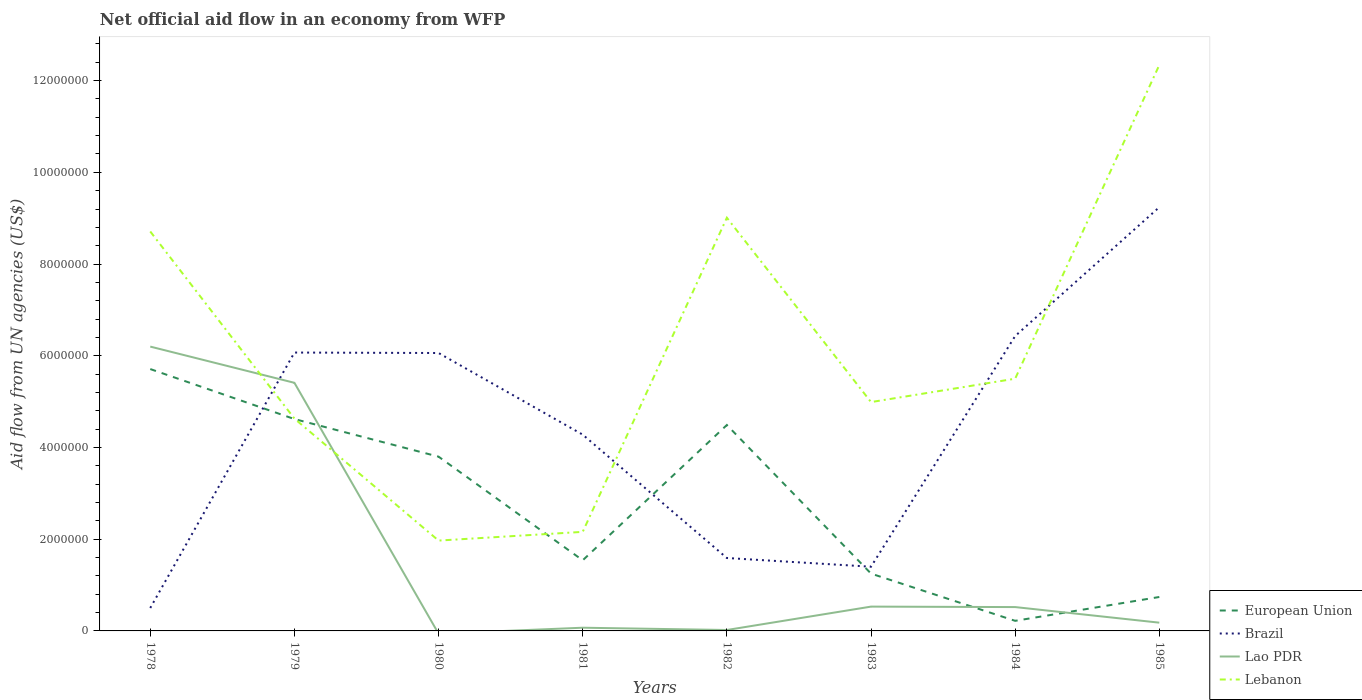How many different coloured lines are there?
Give a very brief answer. 4. Does the line corresponding to European Union intersect with the line corresponding to Lao PDR?
Offer a terse response. Yes. Across all years, what is the maximum net official aid flow in Brazil?
Provide a short and direct response. 5.00e+05. What is the total net official aid flow in European Union in the graph?
Give a very brief answer. 3.08e+06. What is the difference between the highest and the second highest net official aid flow in Lebanon?
Offer a very short reply. 1.04e+07. What is the difference between the highest and the lowest net official aid flow in Lao PDR?
Offer a terse response. 2. How many lines are there?
Provide a succinct answer. 4. How many years are there in the graph?
Give a very brief answer. 8. What is the difference between two consecutive major ticks on the Y-axis?
Provide a succinct answer. 2.00e+06. Are the values on the major ticks of Y-axis written in scientific E-notation?
Provide a short and direct response. No. Does the graph contain any zero values?
Provide a succinct answer. Yes. Does the graph contain grids?
Offer a terse response. No. Where does the legend appear in the graph?
Offer a terse response. Bottom right. How are the legend labels stacked?
Your response must be concise. Vertical. What is the title of the graph?
Offer a very short reply. Net official aid flow in an economy from WFP. Does "Albania" appear as one of the legend labels in the graph?
Make the answer very short. No. What is the label or title of the X-axis?
Your response must be concise. Years. What is the label or title of the Y-axis?
Provide a short and direct response. Aid flow from UN agencies (US$). What is the Aid flow from UN agencies (US$) of European Union in 1978?
Offer a terse response. 5.71e+06. What is the Aid flow from UN agencies (US$) of Lao PDR in 1978?
Your answer should be compact. 6.20e+06. What is the Aid flow from UN agencies (US$) of Lebanon in 1978?
Your answer should be very brief. 8.71e+06. What is the Aid flow from UN agencies (US$) in European Union in 1979?
Your answer should be compact. 4.62e+06. What is the Aid flow from UN agencies (US$) in Brazil in 1979?
Offer a very short reply. 6.07e+06. What is the Aid flow from UN agencies (US$) of Lao PDR in 1979?
Offer a terse response. 5.41e+06. What is the Aid flow from UN agencies (US$) of Lebanon in 1979?
Your answer should be compact. 4.63e+06. What is the Aid flow from UN agencies (US$) of European Union in 1980?
Make the answer very short. 3.80e+06. What is the Aid flow from UN agencies (US$) in Brazil in 1980?
Provide a short and direct response. 6.06e+06. What is the Aid flow from UN agencies (US$) in Lao PDR in 1980?
Offer a very short reply. 0. What is the Aid flow from UN agencies (US$) of Lebanon in 1980?
Your response must be concise. 1.97e+06. What is the Aid flow from UN agencies (US$) of European Union in 1981?
Offer a very short reply. 1.54e+06. What is the Aid flow from UN agencies (US$) of Brazil in 1981?
Provide a short and direct response. 4.28e+06. What is the Aid flow from UN agencies (US$) in Lebanon in 1981?
Offer a very short reply. 2.16e+06. What is the Aid flow from UN agencies (US$) in European Union in 1982?
Your answer should be very brief. 4.49e+06. What is the Aid flow from UN agencies (US$) of Brazil in 1982?
Your response must be concise. 1.59e+06. What is the Aid flow from UN agencies (US$) of Lebanon in 1982?
Your response must be concise. 9.01e+06. What is the Aid flow from UN agencies (US$) of European Union in 1983?
Offer a terse response. 1.25e+06. What is the Aid flow from UN agencies (US$) of Brazil in 1983?
Give a very brief answer. 1.40e+06. What is the Aid flow from UN agencies (US$) of Lao PDR in 1983?
Keep it short and to the point. 5.30e+05. What is the Aid flow from UN agencies (US$) in Lebanon in 1983?
Offer a terse response. 4.99e+06. What is the Aid flow from UN agencies (US$) in Brazil in 1984?
Provide a succinct answer. 6.43e+06. What is the Aid flow from UN agencies (US$) in Lao PDR in 1984?
Keep it short and to the point. 5.20e+05. What is the Aid flow from UN agencies (US$) in Lebanon in 1984?
Your response must be concise. 5.50e+06. What is the Aid flow from UN agencies (US$) in European Union in 1985?
Offer a very short reply. 7.40e+05. What is the Aid flow from UN agencies (US$) of Brazil in 1985?
Your answer should be compact. 9.24e+06. What is the Aid flow from UN agencies (US$) in Lao PDR in 1985?
Give a very brief answer. 1.80e+05. What is the Aid flow from UN agencies (US$) in Lebanon in 1985?
Your answer should be compact. 1.23e+07. Across all years, what is the maximum Aid flow from UN agencies (US$) of European Union?
Ensure brevity in your answer.  5.71e+06. Across all years, what is the maximum Aid flow from UN agencies (US$) of Brazil?
Keep it short and to the point. 9.24e+06. Across all years, what is the maximum Aid flow from UN agencies (US$) in Lao PDR?
Your answer should be compact. 6.20e+06. Across all years, what is the maximum Aid flow from UN agencies (US$) of Lebanon?
Your answer should be compact. 1.23e+07. Across all years, what is the minimum Aid flow from UN agencies (US$) in European Union?
Offer a very short reply. 2.20e+05. Across all years, what is the minimum Aid flow from UN agencies (US$) of Brazil?
Offer a very short reply. 5.00e+05. Across all years, what is the minimum Aid flow from UN agencies (US$) in Lao PDR?
Your response must be concise. 0. Across all years, what is the minimum Aid flow from UN agencies (US$) of Lebanon?
Provide a succinct answer. 1.97e+06. What is the total Aid flow from UN agencies (US$) of European Union in the graph?
Ensure brevity in your answer.  2.24e+07. What is the total Aid flow from UN agencies (US$) of Brazil in the graph?
Provide a short and direct response. 3.56e+07. What is the total Aid flow from UN agencies (US$) of Lao PDR in the graph?
Ensure brevity in your answer.  1.29e+07. What is the total Aid flow from UN agencies (US$) in Lebanon in the graph?
Give a very brief answer. 4.93e+07. What is the difference between the Aid flow from UN agencies (US$) in European Union in 1978 and that in 1979?
Give a very brief answer. 1.09e+06. What is the difference between the Aid flow from UN agencies (US$) of Brazil in 1978 and that in 1979?
Your answer should be very brief. -5.57e+06. What is the difference between the Aid flow from UN agencies (US$) of Lao PDR in 1978 and that in 1979?
Give a very brief answer. 7.90e+05. What is the difference between the Aid flow from UN agencies (US$) in Lebanon in 1978 and that in 1979?
Your answer should be compact. 4.08e+06. What is the difference between the Aid flow from UN agencies (US$) in European Union in 1978 and that in 1980?
Your answer should be compact. 1.91e+06. What is the difference between the Aid flow from UN agencies (US$) of Brazil in 1978 and that in 1980?
Your answer should be compact. -5.56e+06. What is the difference between the Aid flow from UN agencies (US$) of Lebanon in 1978 and that in 1980?
Your response must be concise. 6.74e+06. What is the difference between the Aid flow from UN agencies (US$) in European Union in 1978 and that in 1981?
Offer a terse response. 4.17e+06. What is the difference between the Aid flow from UN agencies (US$) in Brazil in 1978 and that in 1981?
Your response must be concise. -3.78e+06. What is the difference between the Aid flow from UN agencies (US$) of Lao PDR in 1978 and that in 1981?
Keep it short and to the point. 6.13e+06. What is the difference between the Aid flow from UN agencies (US$) in Lebanon in 1978 and that in 1981?
Make the answer very short. 6.55e+06. What is the difference between the Aid flow from UN agencies (US$) of European Union in 1978 and that in 1982?
Your response must be concise. 1.22e+06. What is the difference between the Aid flow from UN agencies (US$) in Brazil in 1978 and that in 1982?
Keep it short and to the point. -1.09e+06. What is the difference between the Aid flow from UN agencies (US$) in Lao PDR in 1978 and that in 1982?
Ensure brevity in your answer.  6.18e+06. What is the difference between the Aid flow from UN agencies (US$) in Lebanon in 1978 and that in 1982?
Provide a short and direct response. -3.00e+05. What is the difference between the Aid flow from UN agencies (US$) of European Union in 1978 and that in 1983?
Offer a very short reply. 4.46e+06. What is the difference between the Aid flow from UN agencies (US$) in Brazil in 1978 and that in 1983?
Offer a very short reply. -9.00e+05. What is the difference between the Aid flow from UN agencies (US$) of Lao PDR in 1978 and that in 1983?
Offer a terse response. 5.67e+06. What is the difference between the Aid flow from UN agencies (US$) of Lebanon in 1978 and that in 1983?
Offer a very short reply. 3.72e+06. What is the difference between the Aid flow from UN agencies (US$) of European Union in 1978 and that in 1984?
Provide a succinct answer. 5.49e+06. What is the difference between the Aid flow from UN agencies (US$) in Brazil in 1978 and that in 1984?
Provide a short and direct response. -5.93e+06. What is the difference between the Aid flow from UN agencies (US$) of Lao PDR in 1978 and that in 1984?
Offer a very short reply. 5.68e+06. What is the difference between the Aid flow from UN agencies (US$) in Lebanon in 1978 and that in 1984?
Ensure brevity in your answer.  3.21e+06. What is the difference between the Aid flow from UN agencies (US$) in European Union in 1978 and that in 1985?
Provide a short and direct response. 4.97e+06. What is the difference between the Aid flow from UN agencies (US$) in Brazil in 1978 and that in 1985?
Offer a very short reply. -8.74e+06. What is the difference between the Aid flow from UN agencies (US$) in Lao PDR in 1978 and that in 1985?
Give a very brief answer. 6.02e+06. What is the difference between the Aid flow from UN agencies (US$) in Lebanon in 1978 and that in 1985?
Provide a succinct answer. -3.63e+06. What is the difference between the Aid flow from UN agencies (US$) of European Union in 1979 and that in 1980?
Offer a terse response. 8.20e+05. What is the difference between the Aid flow from UN agencies (US$) of Lebanon in 1979 and that in 1980?
Ensure brevity in your answer.  2.66e+06. What is the difference between the Aid flow from UN agencies (US$) in European Union in 1979 and that in 1981?
Your answer should be very brief. 3.08e+06. What is the difference between the Aid flow from UN agencies (US$) of Brazil in 1979 and that in 1981?
Offer a very short reply. 1.79e+06. What is the difference between the Aid flow from UN agencies (US$) of Lao PDR in 1979 and that in 1981?
Keep it short and to the point. 5.34e+06. What is the difference between the Aid flow from UN agencies (US$) of Lebanon in 1979 and that in 1981?
Provide a short and direct response. 2.47e+06. What is the difference between the Aid flow from UN agencies (US$) in European Union in 1979 and that in 1982?
Give a very brief answer. 1.30e+05. What is the difference between the Aid flow from UN agencies (US$) in Brazil in 1979 and that in 1982?
Give a very brief answer. 4.48e+06. What is the difference between the Aid flow from UN agencies (US$) in Lao PDR in 1979 and that in 1982?
Provide a succinct answer. 5.39e+06. What is the difference between the Aid flow from UN agencies (US$) in Lebanon in 1979 and that in 1982?
Give a very brief answer. -4.38e+06. What is the difference between the Aid flow from UN agencies (US$) in European Union in 1979 and that in 1983?
Ensure brevity in your answer.  3.37e+06. What is the difference between the Aid flow from UN agencies (US$) of Brazil in 1979 and that in 1983?
Your answer should be very brief. 4.67e+06. What is the difference between the Aid flow from UN agencies (US$) in Lao PDR in 1979 and that in 1983?
Offer a very short reply. 4.88e+06. What is the difference between the Aid flow from UN agencies (US$) of Lebanon in 1979 and that in 1983?
Give a very brief answer. -3.60e+05. What is the difference between the Aid flow from UN agencies (US$) in European Union in 1979 and that in 1984?
Your answer should be compact. 4.40e+06. What is the difference between the Aid flow from UN agencies (US$) in Brazil in 1979 and that in 1984?
Offer a terse response. -3.60e+05. What is the difference between the Aid flow from UN agencies (US$) in Lao PDR in 1979 and that in 1984?
Offer a very short reply. 4.89e+06. What is the difference between the Aid flow from UN agencies (US$) in Lebanon in 1979 and that in 1984?
Your answer should be very brief. -8.70e+05. What is the difference between the Aid flow from UN agencies (US$) in European Union in 1979 and that in 1985?
Your answer should be compact. 3.88e+06. What is the difference between the Aid flow from UN agencies (US$) of Brazil in 1979 and that in 1985?
Your response must be concise. -3.17e+06. What is the difference between the Aid flow from UN agencies (US$) of Lao PDR in 1979 and that in 1985?
Your answer should be very brief. 5.23e+06. What is the difference between the Aid flow from UN agencies (US$) of Lebanon in 1979 and that in 1985?
Your response must be concise. -7.71e+06. What is the difference between the Aid flow from UN agencies (US$) of European Union in 1980 and that in 1981?
Make the answer very short. 2.26e+06. What is the difference between the Aid flow from UN agencies (US$) of Brazil in 1980 and that in 1981?
Make the answer very short. 1.78e+06. What is the difference between the Aid flow from UN agencies (US$) of Lebanon in 1980 and that in 1981?
Give a very brief answer. -1.90e+05. What is the difference between the Aid flow from UN agencies (US$) in European Union in 1980 and that in 1982?
Your answer should be compact. -6.90e+05. What is the difference between the Aid flow from UN agencies (US$) in Brazil in 1980 and that in 1982?
Offer a terse response. 4.47e+06. What is the difference between the Aid flow from UN agencies (US$) of Lebanon in 1980 and that in 1982?
Provide a short and direct response. -7.04e+06. What is the difference between the Aid flow from UN agencies (US$) of European Union in 1980 and that in 1983?
Ensure brevity in your answer.  2.55e+06. What is the difference between the Aid flow from UN agencies (US$) in Brazil in 1980 and that in 1983?
Offer a terse response. 4.66e+06. What is the difference between the Aid flow from UN agencies (US$) of Lebanon in 1980 and that in 1983?
Offer a very short reply. -3.02e+06. What is the difference between the Aid flow from UN agencies (US$) of European Union in 1980 and that in 1984?
Offer a terse response. 3.58e+06. What is the difference between the Aid flow from UN agencies (US$) in Brazil in 1980 and that in 1984?
Make the answer very short. -3.70e+05. What is the difference between the Aid flow from UN agencies (US$) of Lebanon in 1980 and that in 1984?
Ensure brevity in your answer.  -3.53e+06. What is the difference between the Aid flow from UN agencies (US$) in European Union in 1980 and that in 1985?
Keep it short and to the point. 3.06e+06. What is the difference between the Aid flow from UN agencies (US$) in Brazil in 1980 and that in 1985?
Your answer should be very brief. -3.18e+06. What is the difference between the Aid flow from UN agencies (US$) of Lebanon in 1980 and that in 1985?
Offer a very short reply. -1.04e+07. What is the difference between the Aid flow from UN agencies (US$) in European Union in 1981 and that in 1982?
Offer a terse response. -2.95e+06. What is the difference between the Aid flow from UN agencies (US$) of Brazil in 1981 and that in 1982?
Your answer should be compact. 2.69e+06. What is the difference between the Aid flow from UN agencies (US$) in Lao PDR in 1981 and that in 1982?
Offer a very short reply. 5.00e+04. What is the difference between the Aid flow from UN agencies (US$) in Lebanon in 1981 and that in 1982?
Make the answer very short. -6.85e+06. What is the difference between the Aid flow from UN agencies (US$) in Brazil in 1981 and that in 1983?
Ensure brevity in your answer.  2.88e+06. What is the difference between the Aid flow from UN agencies (US$) of Lao PDR in 1981 and that in 1983?
Provide a succinct answer. -4.60e+05. What is the difference between the Aid flow from UN agencies (US$) in Lebanon in 1981 and that in 1983?
Your answer should be very brief. -2.83e+06. What is the difference between the Aid flow from UN agencies (US$) in European Union in 1981 and that in 1984?
Your response must be concise. 1.32e+06. What is the difference between the Aid flow from UN agencies (US$) of Brazil in 1981 and that in 1984?
Make the answer very short. -2.15e+06. What is the difference between the Aid flow from UN agencies (US$) of Lao PDR in 1981 and that in 1984?
Your answer should be very brief. -4.50e+05. What is the difference between the Aid flow from UN agencies (US$) of Lebanon in 1981 and that in 1984?
Give a very brief answer. -3.34e+06. What is the difference between the Aid flow from UN agencies (US$) of Brazil in 1981 and that in 1985?
Keep it short and to the point. -4.96e+06. What is the difference between the Aid flow from UN agencies (US$) in Lao PDR in 1981 and that in 1985?
Give a very brief answer. -1.10e+05. What is the difference between the Aid flow from UN agencies (US$) of Lebanon in 1981 and that in 1985?
Offer a very short reply. -1.02e+07. What is the difference between the Aid flow from UN agencies (US$) in European Union in 1982 and that in 1983?
Keep it short and to the point. 3.24e+06. What is the difference between the Aid flow from UN agencies (US$) in Brazil in 1982 and that in 1983?
Offer a terse response. 1.90e+05. What is the difference between the Aid flow from UN agencies (US$) in Lao PDR in 1982 and that in 1983?
Offer a terse response. -5.10e+05. What is the difference between the Aid flow from UN agencies (US$) in Lebanon in 1982 and that in 1983?
Ensure brevity in your answer.  4.02e+06. What is the difference between the Aid flow from UN agencies (US$) of European Union in 1982 and that in 1984?
Offer a very short reply. 4.27e+06. What is the difference between the Aid flow from UN agencies (US$) in Brazil in 1982 and that in 1984?
Your answer should be very brief. -4.84e+06. What is the difference between the Aid flow from UN agencies (US$) in Lao PDR in 1982 and that in 1984?
Offer a terse response. -5.00e+05. What is the difference between the Aid flow from UN agencies (US$) of Lebanon in 1982 and that in 1984?
Keep it short and to the point. 3.51e+06. What is the difference between the Aid flow from UN agencies (US$) in European Union in 1982 and that in 1985?
Provide a succinct answer. 3.75e+06. What is the difference between the Aid flow from UN agencies (US$) in Brazil in 1982 and that in 1985?
Offer a terse response. -7.65e+06. What is the difference between the Aid flow from UN agencies (US$) of Lao PDR in 1982 and that in 1985?
Make the answer very short. -1.60e+05. What is the difference between the Aid flow from UN agencies (US$) in Lebanon in 1982 and that in 1985?
Your answer should be very brief. -3.33e+06. What is the difference between the Aid flow from UN agencies (US$) of European Union in 1983 and that in 1984?
Provide a succinct answer. 1.03e+06. What is the difference between the Aid flow from UN agencies (US$) in Brazil in 1983 and that in 1984?
Provide a succinct answer. -5.03e+06. What is the difference between the Aid flow from UN agencies (US$) of Lebanon in 1983 and that in 1984?
Make the answer very short. -5.10e+05. What is the difference between the Aid flow from UN agencies (US$) of European Union in 1983 and that in 1985?
Your answer should be very brief. 5.10e+05. What is the difference between the Aid flow from UN agencies (US$) of Brazil in 1983 and that in 1985?
Offer a very short reply. -7.84e+06. What is the difference between the Aid flow from UN agencies (US$) of Lebanon in 1983 and that in 1985?
Your answer should be very brief. -7.35e+06. What is the difference between the Aid flow from UN agencies (US$) in European Union in 1984 and that in 1985?
Your answer should be compact. -5.20e+05. What is the difference between the Aid flow from UN agencies (US$) of Brazil in 1984 and that in 1985?
Give a very brief answer. -2.81e+06. What is the difference between the Aid flow from UN agencies (US$) of Lebanon in 1984 and that in 1985?
Offer a very short reply. -6.84e+06. What is the difference between the Aid flow from UN agencies (US$) in European Union in 1978 and the Aid flow from UN agencies (US$) in Brazil in 1979?
Make the answer very short. -3.60e+05. What is the difference between the Aid flow from UN agencies (US$) in European Union in 1978 and the Aid flow from UN agencies (US$) in Lao PDR in 1979?
Provide a succinct answer. 3.00e+05. What is the difference between the Aid flow from UN agencies (US$) in European Union in 1978 and the Aid flow from UN agencies (US$) in Lebanon in 1979?
Your response must be concise. 1.08e+06. What is the difference between the Aid flow from UN agencies (US$) of Brazil in 1978 and the Aid flow from UN agencies (US$) of Lao PDR in 1979?
Keep it short and to the point. -4.91e+06. What is the difference between the Aid flow from UN agencies (US$) in Brazil in 1978 and the Aid flow from UN agencies (US$) in Lebanon in 1979?
Offer a very short reply. -4.13e+06. What is the difference between the Aid flow from UN agencies (US$) in Lao PDR in 1978 and the Aid flow from UN agencies (US$) in Lebanon in 1979?
Your answer should be compact. 1.57e+06. What is the difference between the Aid flow from UN agencies (US$) in European Union in 1978 and the Aid flow from UN agencies (US$) in Brazil in 1980?
Offer a terse response. -3.50e+05. What is the difference between the Aid flow from UN agencies (US$) in European Union in 1978 and the Aid flow from UN agencies (US$) in Lebanon in 1980?
Offer a very short reply. 3.74e+06. What is the difference between the Aid flow from UN agencies (US$) in Brazil in 1978 and the Aid flow from UN agencies (US$) in Lebanon in 1980?
Offer a terse response. -1.47e+06. What is the difference between the Aid flow from UN agencies (US$) in Lao PDR in 1978 and the Aid flow from UN agencies (US$) in Lebanon in 1980?
Offer a very short reply. 4.23e+06. What is the difference between the Aid flow from UN agencies (US$) of European Union in 1978 and the Aid flow from UN agencies (US$) of Brazil in 1981?
Offer a very short reply. 1.43e+06. What is the difference between the Aid flow from UN agencies (US$) of European Union in 1978 and the Aid flow from UN agencies (US$) of Lao PDR in 1981?
Give a very brief answer. 5.64e+06. What is the difference between the Aid flow from UN agencies (US$) of European Union in 1978 and the Aid flow from UN agencies (US$) of Lebanon in 1981?
Ensure brevity in your answer.  3.55e+06. What is the difference between the Aid flow from UN agencies (US$) in Brazil in 1978 and the Aid flow from UN agencies (US$) in Lebanon in 1981?
Offer a terse response. -1.66e+06. What is the difference between the Aid flow from UN agencies (US$) in Lao PDR in 1978 and the Aid flow from UN agencies (US$) in Lebanon in 1981?
Keep it short and to the point. 4.04e+06. What is the difference between the Aid flow from UN agencies (US$) in European Union in 1978 and the Aid flow from UN agencies (US$) in Brazil in 1982?
Your answer should be compact. 4.12e+06. What is the difference between the Aid flow from UN agencies (US$) in European Union in 1978 and the Aid flow from UN agencies (US$) in Lao PDR in 1982?
Make the answer very short. 5.69e+06. What is the difference between the Aid flow from UN agencies (US$) in European Union in 1978 and the Aid flow from UN agencies (US$) in Lebanon in 1982?
Offer a terse response. -3.30e+06. What is the difference between the Aid flow from UN agencies (US$) of Brazil in 1978 and the Aid flow from UN agencies (US$) of Lebanon in 1982?
Keep it short and to the point. -8.51e+06. What is the difference between the Aid flow from UN agencies (US$) of Lao PDR in 1978 and the Aid flow from UN agencies (US$) of Lebanon in 1982?
Your answer should be very brief. -2.81e+06. What is the difference between the Aid flow from UN agencies (US$) of European Union in 1978 and the Aid flow from UN agencies (US$) of Brazil in 1983?
Provide a short and direct response. 4.31e+06. What is the difference between the Aid flow from UN agencies (US$) in European Union in 1978 and the Aid flow from UN agencies (US$) in Lao PDR in 1983?
Ensure brevity in your answer.  5.18e+06. What is the difference between the Aid flow from UN agencies (US$) in European Union in 1978 and the Aid flow from UN agencies (US$) in Lebanon in 1983?
Offer a very short reply. 7.20e+05. What is the difference between the Aid flow from UN agencies (US$) in Brazil in 1978 and the Aid flow from UN agencies (US$) in Lebanon in 1983?
Offer a terse response. -4.49e+06. What is the difference between the Aid flow from UN agencies (US$) of Lao PDR in 1978 and the Aid flow from UN agencies (US$) of Lebanon in 1983?
Give a very brief answer. 1.21e+06. What is the difference between the Aid flow from UN agencies (US$) in European Union in 1978 and the Aid flow from UN agencies (US$) in Brazil in 1984?
Offer a very short reply. -7.20e+05. What is the difference between the Aid flow from UN agencies (US$) of European Union in 1978 and the Aid flow from UN agencies (US$) of Lao PDR in 1984?
Offer a very short reply. 5.19e+06. What is the difference between the Aid flow from UN agencies (US$) in European Union in 1978 and the Aid flow from UN agencies (US$) in Lebanon in 1984?
Your answer should be compact. 2.10e+05. What is the difference between the Aid flow from UN agencies (US$) in Brazil in 1978 and the Aid flow from UN agencies (US$) in Lao PDR in 1984?
Keep it short and to the point. -2.00e+04. What is the difference between the Aid flow from UN agencies (US$) of Brazil in 1978 and the Aid flow from UN agencies (US$) of Lebanon in 1984?
Offer a very short reply. -5.00e+06. What is the difference between the Aid flow from UN agencies (US$) of European Union in 1978 and the Aid flow from UN agencies (US$) of Brazil in 1985?
Ensure brevity in your answer.  -3.53e+06. What is the difference between the Aid flow from UN agencies (US$) in European Union in 1978 and the Aid flow from UN agencies (US$) in Lao PDR in 1985?
Give a very brief answer. 5.53e+06. What is the difference between the Aid flow from UN agencies (US$) of European Union in 1978 and the Aid flow from UN agencies (US$) of Lebanon in 1985?
Provide a short and direct response. -6.63e+06. What is the difference between the Aid flow from UN agencies (US$) of Brazil in 1978 and the Aid flow from UN agencies (US$) of Lao PDR in 1985?
Your response must be concise. 3.20e+05. What is the difference between the Aid flow from UN agencies (US$) in Brazil in 1978 and the Aid flow from UN agencies (US$) in Lebanon in 1985?
Give a very brief answer. -1.18e+07. What is the difference between the Aid flow from UN agencies (US$) in Lao PDR in 1978 and the Aid flow from UN agencies (US$) in Lebanon in 1985?
Ensure brevity in your answer.  -6.14e+06. What is the difference between the Aid flow from UN agencies (US$) of European Union in 1979 and the Aid flow from UN agencies (US$) of Brazil in 1980?
Ensure brevity in your answer.  -1.44e+06. What is the difference between the Aid flow from UN agencies (US$) in European Union in 1979 and the Aid flow from UN agencies (US$) in Lebanon in 1980?
Offer a terse response. 2.65e+06. What is the difference between the Aid flow from UN agencies (US$) of Brazil in 1979 and the Aid flow from UN agencies (US$) of Lebanon in 1980?
Your answer should be compact. 4.10e+06. What is the difference between the Aid flow from UN agencies (US$) in Lao PDR in 1979 and the Aid flow from UN agencies (US$) in Lebanon in 1980?
Offer a terse response. 3.44e+06. What is the difference between the Aid flow from UN agencies (US$) in European Union in 1979 and the Aid flow from UN agencies (US$) in Brazil in 1981?
Offer a terse response. 3.40e+05. What is the difference between the Aid flow from UN agencies (US$) of European Union in 1979 and the Aid flow from UN agencies (US$) of Lao PDR in 1981?
Provide a succinct answer. 4.55e+06. What is the difference between the Aid flow from UN agencies (US$) of European Union in 1979 and the Aid flow from UN agencies (US$) of Lebanon in 1981?
Your response must be concise. 2.46e+06. What is the difference between the Aid flow from UN agencies (US$) of Brazil in 1979 and the Aid flow from UN agencies (US$) of Lao PDR in 1981?
Your response must be concise. 6.00e+06. What is the difference between the Aid flow from UN agencies (US$) of Brazil in 1979 and the Aid flow from UN agencies (US$) of Lebanon in 1981?
Give a very brief answer. 3.91e+06. What is the difference between the Aid flow from UN agencies (US$) of Lao PDR in 1979 and the Aid flow from UN agencies (US$) of Lebanon in 1981?
Offer a very short reply. 3.25e+06. What is the difference between the Aid flow from UN agencies (US$) of European Union in 1979 and the Aid flow from UN agencies (US$) of Brazil in 1982?
Provide a short and direct response. 3.03e+06. What is the difference between the Aid flow from UN agencies (US$) of European Union in 1979 and the Aid flow from UN agencies (US$) of Lao PDR in 1982?
Provide a succinct answer. 4.60e+06. What is the difference between the Aid flow from UN agencies (US$) in European Union in 1979 and the Aid flow from UN agencies (US$) in Lebanon in 1982?
Provide a succinct answer. -4.39e+06. What is the difference between the Aid flow from UN agencies (US$) of Brazil in 1979 and the Aid flow from UN agencies (US$) of Lao PDR in 1982?
Your answer should be compact. 6.05e+06. What is the difference between the Aid flow from UN agencies (US$) in Brazil in 1979 and the Aid flow from UN agencies (US$) in Lebanon in 1982?
Make the answer very short. -2.94e+06. What is the difference between the Aid flow from UN agencies (US$) in Lao PDR in 1979 and the Aid flow from UN agencies (US$) in Lebanon in 1982?
Give a very brief answer. -3.60e+06. What is the difference between the Aid flow from UN agencies (US$) of European Union in 1979 and the Aid flow from UN agencies (US$) of Brazil in 1983?
Ensure brevity in your answer.  3.22e+06. What is the difference between the Aid flow from UN agencies (US$) in European Union in 1979 and the Aid flow from UN agencies (US$) in Lao PDR in 1983?
Give a very brief answer. 4.09e+06. What is the difference between the Aid flow from UN agencies (US$) of European Union in 1979 and the Aid flow from UN agencies (US$) of Lebanon in 1983?
Offer a terse response. -3.70e+05. What is the difference between the Aid flow from UN agencies (US$) in Brazil in 1979 and the Aid flow from UN agencies (US$) in Lao PDR in 1983?
Provide a short and direct response. 5.54e+06. What is the difference between the Aid flow from UN agencies (US$) of Brazil in 1979 and the Aid flow from UN agencies (US$) of Lebanon in 1983?
Keep it short and to the point. 1.08e+06. What is the difference between the Aid flow from UN agencies (US$) of European Union in 1979 and the Aid flow from UN agencies (US$) of Brazil in 1984?
Give a very brief answer. -1.81e+06. What is the difference between the Aid flow from UN agencies (US$) in European Union in 1979 and the Aid flow from UN agencies (US$) in Lao PDR in 1984?
Your answer should be very brief. 4.10e+06. What is the difference between the Aid flow from UN agencies (US$) of European Union in 1979 and the Aid flow from UN agencies (US$) of Lebanon in 1984?
Keep it short and to the point. -8.80e+05. What is the difference between the Aid flow from UN agencies (US$) in Brazil in 1979 and the Aid flow from UN agencies (US$) in Lao PDR in 1984?
Give a very brief answer. 5.55e+06. What is the difference between the Aid flow from UN agencies (US$) in Brazil in 1979 and the Aid flow from UN agencies (US$) in Lebanon in 1984?
Your answer should be compact. 5.70e+05. What is the difference between the Aid flow from UN agencies (US$) of Lao PDR in 1979 and the Aid flow from UN agencies (US$) of Lebanon in 1984?
Give a very brief answer. -9.00e+04. What is the difference between the Aid flow from UN agencies (US$) of European Union in 1979 and the Aid flow from UN agencies (US$) of Brazil in 1985?
Offer a terse response. -4.62e+06. What is the difference between the Aid flow from UN agencies (US$) in European Union in 1979 and the Aid flow from UN agencies (US$) in Lao PDR in 1985?
Your answer should be very brief. 4.44e+06. What is the difference between the Aid flow from UN agencies (US$) in European Union in 1979 and the Aid flow from UN agencies (US$) in Lebanon in 1985?
Make the answer very short. -7.72e+06. What is the difference between the Aid flow from UN agencies (US$) in Brazil in 1979 and the Aid flow from UN agencies (US$) in Lao PDR in 1985?
Your response must be concise. 5.89e+06. What is the difference between the Aid flow from UN agencies (US$) of Brazil in 1979 and the Aid flow from UN agencies (US$) of Lebanon in 1985?
Your answer should be very brief. -6.27e+06. What is the difference between the Aid flow from UN agencies (US$) of Lao PDR in 1979 and the Aid flow from UN agencies (US$) of Lebanon in 1985?
Offer a terse response. -6.93e+06. What is the difference between the Aid flow from UN agencies (US$) in European Union in 1980 and the Aid flow from UN agencies (US$) in Brazil in 1981?
Make the answer very short. -4.80e+05. What is the difference between the Aid flow from UN agencies (US$) of European Union in 1980 and the Aid flow from UN agencies (US$) of Lao PDR in 1981?
Give a very brief answer. 3.73e+06. What is the difference between the Aid flow from UN agencies (US$) of European Union in 1980 and the Aid flow from UN agencies (US$) of Lebanon in 1981?
Give a very brief answer. 1.64e+06. What is the difference between the Aid flow from UN agencies (US$) of Brazil in 1980 and the Aid flow from UN agencies (US$) of Lao PDR in 1981?
Your response must be concise. 5.99e+06. What is the difference between the Aid flow from UN agencies (US$) of Brazil in 1980 and the Aid flow from UN agencies (US$) of Lebanon in 1981?
Provide a short and direct response. 3.90e+06. What is the difference between the Aid flow from UN agencies (US$) in European Union in 1980 and the Aid flow from UN agencies (US$) in Brazil in 1982?
Your answer should be very brief. 2.21e+06. What is the difference between the Aid flow from UN agencies (US$) in European Union in 1980 and the Aid flow from UN agencies (US$) in Lao PDR in 1982?
Your answer should be compact. 3.78e+06. What is the difference between the Aid flow from UN agencies (US$) in European Union in 1980 and the Aid flow from UN agencies (US$) in Lebanon in 1982?
Provide a short and direct response. -5.21e+06. What is the difference between the Aid flow from UN agencies (US$) in Brazil in 1980 and the Aid flow from UN agencies (US$) in Lao PDR in 1982?
Keep it short and to the point. 6.04e+06. What is the difference between the Aid flow from UN agencies (US$) of Brazil in 1980 and the Aid flow from UN agencies (US$) of Lebanon in 1982?
Your answer should be compact. -2.95e+06. What is the difference between the Aid flow from UN agencies (US$) of European Union in 1980 and the Aid flow from UN agencies (US$) of Brazil in 1983?
Your response must be concise. 2.40e+06. What is the difference between the Aid flow from UN agencies (US$) in European Union in 1980 and the Aid flow from UN agencies (US$) in Lao PDR in 1983?
Give a very brief answer. 3.27e+06. What is the difference between the Aid flow from UN agencies (US$) of European Union in 1980 and the Aid flow from UN agencies (US$) of Lebanon in 1983?
Ensure brevity in your answer.  -1.19e+06. What is the difference between the Aid flow from UN agencies (US$) in Brazil in 1980 and the Aid flow from UN agencies (US$) in Lao PDR in 1983?
Keep it short and to the point. 5.53e+06. What is the difference between the Aid flow from UN agencies (US$) in Brazil in 1980 and the Aid flow from UN agencies (US$) in Lebanon in 1983?
Offer a terse response. 1.07e+06. What is the difference between the Aid flow from UN agencies (US$) in European Union in 1980 and the Aid flow from UN agencies (US$) in Brazil in 1984?
Make the answer very short. -2.63e+06. What is the difference between the Aid flow from UN agencies (US$) in European Union in 1980 and the Aid flow from UN agencies (US$) in Lao PDR in 1984?
Offer a very short reply. 3.28e+06. What is the difference between the Aid flow from UN agencies (US$) in European Union in 1980 and the Aid flow from UN agencies (US$) in Lebanon in 1984?
Give a very brief answer. -1.70e+06. What is the difference between the Aid flow from UN agencies (US$) in Brazil in 1980 and the Aid flow from UN agencies (US$) in Lao PDR in 1984?
Provide a short and direct response. 5.54e+06. What is the difference between the Aid flow from UN agencies (US$) of Brazil in 1980 and the Aid flow from UN agencies (US$) of Lebanon in 1984?
Offer a terse response. 5.60e+05. What is the difference between the Aid flow from UN agencies (US$) of European Union in 1980 and the Aid flow from UN agencies (US$) of Brazil in 1985?
Give a very brief answer. -5.44e+06. What is the difference between the Aid flow from UN agencies (US$) in European Union in 1980 and the Aid flow from UN agencies (US$) in Lao PDR in 1985?
Your answer should be compact. 3.62e+06. What is the difference between the Aid flow from UN agencies (US$) in European Union in 1980 and the Aid flow from UN agencies (US$) in Lebanon in 1985?
Offer a very short reply. -8.54e+06. What is the difference between the Aid flow from UN agencies (US$) of Brazil in 1980 and the Aid flow from UN agencies (US$) of Lao PDR in 1985?
Provide a succinct answer. 5.88e+06. What is the difference between the Aid flow from UN agencies (US$) in Brazil in 1980 and the Aid flow from UN agencies (US$) in Lebanon in 1985?
Keep it short and to the point. -6.28e+06. What is the difference between the Aid flow from UN agencies (US$) of European Union in 1981 and the Aid flow from UN agencies (US$) of Brazil in 1982?
Keep it short and to the point. -5.00e+04. What is the difference between the Aid flow from UN agencies (US$) of European Union in 1981 and the Aid flow from UN agencies (US$) of Lao PDR in 1982?
Provide a short and direct response. 1.52e+06. What is the difference between the Aid flow from UN agencies (US$) of European Union in 1981 and the Aid flow from UN agencies (US$) of Lebanon in 1982?
Provide a short and direct response. -7.47e+06. What is the difference between the Aid flow from UN agencies (US$) in Brazil in 1981 and the Aid flow from UN agencies (US$) in Lao PDR in 1982?
Your answer should be very brief. 4.26e+06. What is the difference between the Aid flow from UN agencies (US$) of Brazil in 1981 and the Aid flow from UN agencies (US$) of Lebanon in 1982?
Keep it short and to the point. -4.73e+06. What is the difference between the Aid flow from UN agencies (US$) in Lao PDR in 1981 and the Aid flow from UN agencies (US$) in Lebanon in 1982?
Make the answer very short. -8.94e+06. What is the difference between the Aid flow from UN agencies (US$) of European Union in 1981 and the Aid flow from UN agencies (US$) of Brazil in 1983?
Offer a terse response. 1.40e+05. What is the difference between the Aid flow from UN agencies (US$) of European Union in 1981 and the Aid flow from UN agencies (US$) of Lao PDR in 1983?
Provide a succinct answer. 1.01e+06. What is the difference between the Aid flow from UN agencies (US$) of European Union in 1981 and the Aid flow from UN agencies (US$) of Lebanon in 1983?
Your response must be concise. -3.45e+06. What is the difference between the Aid flow from UN agencies (US$) of Brazil in 1981 and the Aid flow from UN agencies (US$) of Lao PDR in 1983?
Keep it short and to the point. 3.75e+06. What is the difference between the Aid flow from UN agencies (US$) in Brazil in 1981 and the Aid flow from UN agencies (US$) in Lebanon in 1983?
Provide a short and direct response. -7.10e+05. What is the difference between the Aid flow from UN agencies (US$) of Lao PDR in 1981 and the Aid flow from UN agencies (US$) of Lebanon in 1983?
Provide a short and direct response. -4.92e+06. What is the difference between the Aid flow from UN agencies (US$) in European Union in 1981 and the Aid flow from UN agencies (US$) in Brazil in 1984?
Your answer should be compact. -4.89e+06. What is the difference between the Aid flow from UN agencies (US$) of European Union in 1981 and the Aid flow from UN agencies (US$) of Lao PDR in 1984?
Offer a terse response. 1.02e+06. What is the difference between the Aid flow from UN agencies (US$) in European Union in 1981 and the Aid flow from UN agencies (US$) in Lebanon in 1984?
Make the answer very short. -3.96e+06. What is the difference between the Aid flow from UN agencies (US$) in Brazil in 1981 and the Aid flow from UN agencies (US$) in Lao PDR in 1984?
Your answer should be very brief. 3.76e+06. What is the difference between the Aid flow from UN agencies (US$) of Brazil in 1981 and the Aid flow from UN agencies (US$) of Lebanon in 1984?
Provide a short and direct response. -1.22e+06. What is the difference between the Aid flow from UN agencies (US$) of Lao PDR in 1981 and the Aid flow from UN agencies (US$) of Lebanon in 1984?
Your answer should be compact. -5.43e+06. What is the difference between the Aid flow from UN agencies (US$) in European Union in 1981 and the Aid flow from UN agencies (US$) in Brazil in 1985?
Provide a short and direct response. -7.70e+06. What is the difference between the Aid flow from UN agencies (US$) in European Union in 1981 and the Aid flow from UN agencies (US$) in Lao PDR in 1985?
Ensure brevity in your answer.  1.36e+06. What is the difference between the Aid flow from UN agencies (US$) of European Union in 1981 and the Aid flow from UN agencies (US$) of Lebanon in 1985?
Keep it short and to the point. -1.08e+07. What is the difference between the Aid flow from UN agencies (US$) in Brazil in 1981 and the Aid flow from UN agencies (US$) in Lao PDR in 1985?
Give a very brief answer. 4.10e+06. What is the difference between the Aid flow from UN agencies (US$) in Brazil in 1981 and the Aid flow from UN agencies (US$) in Lebanon in 1985?
Your response must be concise. -8.06e+06. What is the difference between the Aid flow from UN agencies (US$) in Lao PDR in 1981 and the Aid flow from UN agencies (US$) in Lebanon in 1985?
Provide a succinct answer. -1.23e+07. What is the difference between the Aid flow from UN agencies (US$) in European Union in 1982 and the Aid flow from UN agencies (US$) in Brazil in 1983?
Give a very brief answer. 3.09e+06. What is the difference between the Aid flow from UN agencies (US$) in European Union in 1982 and the Aid flow from UN agencies (US$) in Lao PDR in 1983?
Offer a very short reply. 3.96e+06. What is the difference between the Aid flow from UN agencies (US$) of European Union in 1982 and the Aid flow from UN agencies (US$) of Lebanon in 1983?
Your answer should be very brief. -5.00e+05. What is the difference between the Aid flow from UN agencies (US$) in Brazil in 1982 and the Aid flow from UN agencies (US$) in Lao PDR in 1983?
Provide a succinct answer. 1.06e+06. What is the difference between the Aid flow from UN agencies (US$) of Brazil in 1982 and the Aid flow from UN agencies (US$) of Lebanon in 1983?
Make the answer very short. -3.40e+06. What is the difference between the Aid flow from UN agencies (US$) of Lao PDR in 1982 and the Aid flow from UN agencies (US$) of Lebanon in 1983?
Keep it short and to the point. -4.97e+06. What is the difference between the Aid flow from UN agencies (US$) in European Union in 1982 and the Aid flow from UN agencies (US$) in Brazil in 1984?
Ensure brevity in your answer.  -1.94e+06. What is the difference between the Aid flow from UN agencies (US$) of European Union in 1982 and the Aid flow from UN agencies (US$) of Lao PDR in 1984?
Keep it short and to the point. 3.97e+06. What is the difference between the Aid flow from UN agencies (US$) of European Union in 1982 and the Aid flow from UN agencies (US$) of Lebanon in 1984?
Give a very brief answer. -1.01e+06. What is the difference between the Aid flow from UN agencies (US$) of Brazil in 1982 and the Aid flow from UN agencies (US$) of Lao PDR in 1984?
Provide a short and direct response. 1.07e+06. What is the difference between the Aid flow from UN agencies (US$) in Brazil in 1982 and the Aid flow from UN agencies (US$) in Lebanon in 1984?
Provide a succinct answer. -3.91e+06. What is the difference between the Aid flow from UN agencies (US$) in Lao PDR in 1982 and the Aid flow from UN agencies (US$) in Lebanon in 1984?
Offer a very short reply. -5.48e+06. What is the difference between the Aid flow from UN agencies (US$) in European Union in 1982 and the Aid flow from UN agencies (US$) in Brazil in 1985?
Your answer should be very brief. -4.75e+06. What is the difference between the Aid flow from UN agencies (US$) of European Union in 1982 and the Aid flow from UN agencies (US$) of Lao PDR in 1985?
Keep it short and to the point. 4.31e+06. What is the difference between the Aid flow from UN agencies (US$) of European Union in 1982 and the Aid flow from UN agencies (US$) of Lebanon in 1985?
Provide a succinct answer. -7.85e+06. What is the difference between the Aid flow from UN agencies (US$) in Brazil in 1982 and the Aid flow from UN agencies (US$) in Lao PDR in 1985?
Provide a succinct answer. 1.41e+06. What is the difference between the Aid flow from UN agencies (US$) in Brazil in 1982 and the Aid flow from UN agencies (US$) in Lebanon in 1985?
Your response must be concise. -1.08e+07. What is the difference between the Aid flow from UN agencies (US$) in Lao PDR in 1982 and the Aid flow from UN agencies (US$) in Lebanon in 1985?
Offer a terse response. -1.23e+07. What is the difference between the Aid flow from UN agencies (US$) of European Union in 1983 and the Aid flow from UN agencies (US$) of Brazil in 1984?
Your response must be concise. -5.18e+06. What is the difference between the Aid flow from UN agencies (US$) in European Union in 1983 and the Aid flow from UN agencies (US$) in Lao PDR in 1984?
Your answer should be compact. 7.30e+05. What is the difference between the Aid flow from UN agencies (US$) of European Union in 1983 and the Aid flow from UN agencies (US$) of Lebanon in 1984?
Ensure brevity in your answer.  -4.25e+06. What is the difference between the Aid flow from UN agencies (US$) of Brazil in 1983 and the Aid flow from UN agencies (US$) of Lao PDR in 1984?
Provide a short and direct response. 8.80e+05. What is the difference between the Aid flow from UN agencies (US$) in Brazil in 1983 and the Aid flow from UN agencies (US$) in Lebanon in 1984?
Make the answer very short. -4.10e+06. What is the difference between the Aid flow from UN agencies (US$) in Lao PDR in 1983 and the Aid flow from UN agencies (US$) in Lebanon in 1984?
Keep it short and to the point. -4.97e+06. What is the difference between the Aid flow from UN agencies (US$) in European Union in 1983 and the Aid flow from UN agencies (US$) in Brazil in 1985?
Keep it short and to the point. -7.99e+06. What is the difference between the Aid flow from UN agencies (US$) in European Union in 1983 and the Aid flow from UN agencies (US$) in Lao PDR in 1985?
Give a very brief answer. 1.07e+06. What is the difference between the Aid flow from UN agencies (US$) in European Union in 1983 and the Aid flow from UN agencies (US$) in Lebanon in 1985?
Offer a very short reply. -1.11e+07. What is the difference between the Aid flow from UN agencies (US$) of Brazil in 1983 and the Aid flow from UN agencies (US$) of Lao PDR in 1985?
Offer a terse response. 1.22e+06. What is the difference between the Aid flow from UN agencies (US$) in Brazil in 1983 and the Aid flow from UN agencies (US$) in Lebanon in 1985?
Provide a succinct answer. -1.09e+07. What is the difference between the Aid flow from UN agencies (US$) of Lao PDR in 1983 and the Aid flow from UN agencies (US$) of Lebanon in 1985?
Make the answer very short. -1.18e+07. What is the difference between the Aid flow from UN agencies (US$) in European Union in 1984 and the Aid flow from UN agencies (US$) in Brazil in 1985?
Your answer should be compact. -9.02e+06. What is the difference between the Aid flow from UN agencies (US$) in European Union in 1984 and the Aid flow from UN agencies (US$) in Lebanon in 1985?
Keep it short and to the point. -1.21e+07. What is the difference between the Aid flow from UN agencies (US$) of Brazil in 1984 and the Aid flow from UN agencies (US$) of Lao PDR in 1985?
Provide a succinct answer. 6.25e+06. What is the difference between the Aid flow from UN agencies (US$) of Brazil in 1984 and the Aid flow from UN agencies (US$) of Lebanon in 1985?
Provide a short and direct response. -5.91e+06. What is the difference between the Aid flow from UN agencies (US$) in Lao PDR in 1984 and the Aid flow from UN agencies (US$) in Lebanon in 1985?
Your answer should be very brief. -1.18e+07. What is the average Aid flow from UN agencies (US$) in European Union per year?
Your answer should be compact. 2.80e+06. What is the average Aid flow from UN agencies (US$) of Brazil per year?
Provide a short and direct response. 4.45e+06. What is the average Aid flow from UN agencies (US$) in Lao PDR per year?
Give a very brief answer. 1.62e+06. What is the average Aid flow from UN agencies (US$) in Lebanon per year?
Make the answer very short. 6.16e+06. In the year 1978, what is the difference between the Aid flow from UN agencies (US$) in European Union and Aid flow from UN agencies (US$) in Brazil?
Offer a very short reply. 5.21e+06. In the year 1978, what is the difference between the Aid flow from UN agencies (US$) in European Union and Aid flow from UN agencies (US$) in Lao PDR?
Your answer should be very brief. -4.90e+05. In the year 1978, what is the difference between the Aid flow from UN agencies (US$) of European Union and Aid flow from UN agencies (US$) of Lebanon?
Make the answer very short. -3.00e+06. In the year 1978, what is the difference between the Aid flow from UN agencies (US$) in Brazil and Aid flow from UN agencies (US$) in Lao PDR?
Offer a terse response. -5.70e+06. In the year 1978, what is the difference between the Aid flow from UN agencies (US$) of Brazil and Aid flow from UN agencies (US$) of Lebanon?
Your answer should be compact. -8.21e+06. In the year 1978, what is the difference between the Aid flow from UN agencies (US$) in Lao PDR and Aid flow from UN agencies (US$) in Lebanon?
Give a very brief answer. -2.51e+06. In the year 1979, what is the difference between the Aid flow from UN agencies (US$) of European Union and Aid flow from UN agencies (US$) of Brazil?
Your answer should be very brief. -1.45e+06. In the year 1979, what is the difference between the Aid flow from UN agencies (US$) of European Union and Aid flow from UN agencies (US$) of Lao PDR?
Make the answer very short. -7.90e+05. In the year 1979, what is the difference between the Aid flow from UN agencies (US$) in Brazil and Aid flow from UN agencies (US$) in Lao PDR?
Ensure brevity in your answer.  6.60e+05. In the year 1979, what is the difference between the Aid flow from UN agencies (US$) in Brazil and Aid flow from UN agencies (US$) in Lebanon?
Your answer should be compact. 1.44e+06. In the year 1979, what is the difference between the Aid flow from UN agencies (US$) of Lao PDR and Aid flow from UN agencies (US$) of Lebanon?
Your answer should be compact. 7.80e+05. In the year 1980, what is the difference between the Aid flow from UN agencies (US$) of European Union and Aid flow from UN agencies (US$) of Brazil?
Ensure brevity in your answer.  -2.26e+06. In the year 1980, what is the difference between the Aid flow from UN agencies (US$) of European Union and Aid flow from UN agencies (US$) of Lebanon?
Your response must be concise. 1.83e+06. In the year 1980, what is the difference between the Aid flow from UN agencies (US$) of Brazil and Aid flow from UN agencies (US$) of Lebanon?
Give a very brief answer. 4.09e+06. In the year 1981, what is the difference between the Aid flow from UN agencies (US$) of European Union and Aid flow from UN agencies (US$) of Brazil?
Ensure brevity in your answer.  -2.74e+06. In the year 1981, what is the difference between the Aid flow from UN agencies (US$) in European Union and Aid flow from UN agencies (US$) in Lao PDR?
Make the answer very short. 1.47e+06. In the year 1981, what is the difference between the Aid flow from UN agencies (US$) of European Union and Aid flow from UN agencies (US$) of Lebanon?
Provide a short and direct response. -6.20e+05. In the year 1981, what is the difference between the Aid flow from UN agencies (US$) in Brazil and Aid flow from UN agencies (US$) in Lao PDR?
Your answer should be very brief. 4.21e+06. In the year 1981, what is the difference between the Aid flow from UN agencies (US$) of Brazil and Aid flow from UN agencies (US$) of Lebanon?
Make the answer very short. 2.12e+06. In the year 1981, what is the difference between the Aid flow from UN agencies (US$) in Lao PDR and Aid flow from UN agencies (US$) in Lebanon?
Provide a succinct answer. -2.09e+06. In the year 1982, what is the difference between the Aid flow from UN agencies (US$) of European Union and Aid flow from UN agencies (US$) of Brazil?
Your answer should be very brief. 2.90e+06. In the year 1982, what is the difference between the Aid flow from UN agencies (US$) in European Union and Aid flow from UN agencies (US$) in Lao PDR?
Your response must be concise. 4.47e+06. In the year 1982, what is the difference between the Aid flow from UN agencies (US$) in European Union and Aid flow from UN agencies (US$) in Lebanon?
Give a very brief answer. -4.52e+06. In the year 1982, what is the difference between the Aid flow from UN agencies (US$) of Brazil and Aid flow from UN agencies (US$) of Lao PDR?
Offer a very short reply. 1.57e+06. In the year 1982, what is the difference between the Aid flow from UN agencies (US$) of Brazil and Aid flow from UN agencies (US$) of Lebanon?
Make the answer very short. -7.42e+06. In the year 1982, what is the difference between the Aid flow from UN agencies (US$) in Lao PDR and Aid flow from UN agencies (US$) in Lebanon?
Keep it short and to the point. -8.99e+06. In the year 1983, what is the difference between the Aid flow from UN agencies (US$) in European Union and Aid flow from UN agencies (US$) in Lao PDR?
Make the answer very short. 7.20e+05. In the year 1983, what is the difference between the Aid flow from UN agencies (US$) of European Union and Aid flow from UN agencies (US$) of Lebanon?
Give a very brief answer. -3.74e+06. In the year 1983, what is the difference between the Aid flow from UN agencies (US$) of Brazil and Aid flow from UN agencies (US$) of Lao PDR?
Your answer should be compact. 8.70e+05. In the year 1983, what is the difference between the Aid flow from UN agencies (US$) of Brazil and Aid flow from UN agencies (US$) of Lebanon?
Offer a terse response. -3.59e+06. In the year 1983, what is the difference between the Aid flow from UN agencies (US$) of Lao PDR and Aid flow from UN agencies (US$) of Lebanon?
Make the answer very short. -4.46e+06. In the year 1984, what is the difference between the Aid flow from UN agencies (US$) in European Union and Aid flow from UN agencies (US$) in Brazil?
Provide a succinct answer. -6.21e+06. In the year 1984, what is the difference between the Aid flow from UN agencies (US$) of European Union and Aid flow from UN agencies (US$) of Lao PDR?
Offer a terse response. -3.00e+05. In the year 1984, what is the difference between the Aid flow from UN agencies (US$) of European Union and Aid flow from UN agencies (US$) of Lebanon?
Offer a very short reply. -5.28e+06. In the year 1984, what is the difference between the Aid flow from UN agencies (US$) of Brazil and Aid flow from UN agencies (US$) of Lao PDR?
Make the answer very short. 5.91e+06. In the year 1984, what is the difference between the Aid flow from UN agencies (US$) in Brazil and Aid flow from UN agencies (US$) in Lebanon?
Your answer should be very brief. 9.30e+05. In the year 1984, what is the difference between the Aid flow from UN agencies (US$) in Lao PDR and Aid flow from UN agencies (US$) in Lebanon?
Provide a short and direct response. -4.98e+06. In the year 1985, what is the difference between the Aid flow from UN agencies (US$) of European Union and Aid flow from UN agencies (US$) of Brazil?
Your answer should be very brief. -8.50e+06. In the year 1985, what is the difference between the Aid flow from UN agencies (US$) in European Union and Aid flow from UN agencies (US$) in Lao PDR?
Provide a succinct answer. 5.60e+05. In the year 1985, what is the difference between the Aid flow from UN agencies (US$) of European Union and Aid flow from UN agencies (US$) of Lebanon?
Make the answer very short. -1.16e+07. In the year 1985, what is the difference between the Aid flow from UN agencies (US$) of Brazil and Aid flow from UN agencies (US$) of Lao PDR?
Offer a very short reply. 9.06e+06. In the year 1985, what is the difference between the Aid flow from UN agencies (US$) of Brazil and Aid flow from UN agencies (US$) of Lebanon?
Your response must be concise. -3.10e+06. In the year 1985, what is the difference between the Aid flow from UN agencies (US$) of Lao PDR and Aid flow from UN agencies (US$) of Lebanon?
Offer a very short reply. -1.22e+07. What is the ratio of the Aid flow from UN agencies (US$) of European Union in 1978 to that in 1979?
Ensure brevity in your answer.  1.24. What is the ratio of the Aid flow from UN agencies (US$) of Brazil in 1978 to that in 1979?
Give a very brief answer. 0.08. What is the ratio of the Aid flow from UN agencies (US$) of Lao PDR in 1978 to that in 1979?
Your answer should be very brief. 1.15. What is the ratio of the Aid flow from UN agencies (US$) in Lebanon in 1978 to that in 1979?
Your answer should be compact. 1.88. What is the ratio of the Aid flow from UN agencies (US$) in European Union in 1978 to that in 1980?
Your response must be concise. 1.5. What is the ratio of the Aid flow from UN agencies (US$) of Brazil in 1978 to that in 1980?
Make the answer very short. 0.08. What is the ratio of the Aid flow from UN agencies (US$) in Lebanon in 1978 to that in 1980?
Make the answer very short. 4.42. What is the ratio of the Aid flow from UN agencies (US$) of European Union in 1978 to that in 1981?
Offer a terse response. 3.71. What is the ratio of the Aid flow from UN agencies (US$) of Brazil in 1978 to that in 1981?
Keep it short and to the point. 0.12. What is the ratio of the Aid flow from UN agencies (US$) of Lao PDR in 1978 to that in 1981?
Make the answer very short. 88.57. What is the ratio of the Aid flow from UN agencies (US$) of Lebanon in 1978 to that in 1981?
Offer a very short reply. 4.03. What is the ratio of the Aid flow from UN agencies (US$) of European Union in 1978 to that in 1982?
Your answer should be very brief. 1.27. What is the ratio of the Aid flow from UN agencies (US$) of Brazil in 1978 to that in 1982?
Offer a terse response. 0.31. What is the ratio of the Aid flow from UN agencies (US$) of Lao PDR in 1978 to that in 1982?
Your answer should be compact. 310. What is the ratio of the Aid flow from UN agencies (US$) in Lebanon in 1978 to that in 1982?
Ensure brevity in your answer.  0.97. What is the ratio of the Aid flow from UN agencies (US$) in European Union in 1978 to that in 1983?
Your answer should be very brief. 4.57. What is the ratio of the Aid flow from UN agencies (US$) in Brazil in 1978 to that in 1983?
Offer a terse response. 0.36. What is the ratio of the Aid flow from UN agencies (US$) of Lao PDR in 1978 to that in 1983?
Provide a short and direct response. 11.7. What is the ratio of the Aid flow from UN agencies (US$) in Lebanon in 1978 to that in 1983?
Give a very brief answer. 1.75. What is the ratio of the Aid flow from UN agencies (US$) of European Union in 1978 to that in 1984?
Your response must be concise. 25.95. What is the ratio of the Aid flow from UN agencies (US$) of Brazil in 1978 to that in 1984?
Give a very brief answer. 0.08. What is the ratio of the Aid flow from UN agencies (US$) in Lao PDR in 1978 to that in 1984?
Offer a very short reply. 11.92. What is the ratio of the Aid flow from UN agencies (US$) of Lebanon in 1978 to that in 1984?
Provide a succinct answer. 1.58. What is the ratio of the Aid flow from UN agencies (US$) of European Union in 1978 to that in 1985?
Provide a short and direct response. 7.72. What is the ratio of the Aid flow from UN agencies (US$) in Brazil in 1978 to that in 1985?
Keep it short and to the point. 0.05. What is the ratio of the Aid flow from UN agencies (US$) of Lao PDR in 1978 to that in 1985?
Give a very brief answer. 34.44. What is the ratio of the Aid flow from UN agencies (US$) in Lebanon in 1978 to that in 1985?
Provide a succinct answer. 0.71. What is the ratio of the Aid flow from UN agencies (US$) in European Union in 1979 to that in 1980?
Provide a succinct answer. 1.22. What is the ratio of the Aid flow from UN agencies (US$) of Lebanon in 1979 to that in 1980?
Your response must be concise. 2.35. What is the ratio of the Aid flow from UN agencies (US$) of European Union in 1979 to that in 1981?
Offer a very short reply. 3. What is the ratio of the Aid flow from UN agencies (US$) of Brazil in 1979 to that in 1981?
Offer a very short reply. 1.42. What is the ratio of the Aid flow from UN agencies (US$) of Lao PDR in 1979 to that in 1981?
Keep it short and to the point. 77.29. What is the ratio of the Aid flow from UN agencies (US$) in Lebanon in 1979 to that in 1981?
Your response must be concise. 2.14. What is the ratio of the Aid flow from UN agencies (US$) in Brazil in 1979 to that in 1982?
Keep it short and to the point. 3.82. What is the ratio of the Aid flow from UN agencies (US$) in Lao PDR in 1979 to that in 1982?
Keep it short and to the point. 270.5. What is the ratio of the Aid flow from UN agencies (US$) in Lebanon in 1979 to that in 1982?
Keep it short and to the point. 0.51. What is the ratio of the Aid flow from UN agencies (US$) in European Union in 1979 to that in 1983?
Give a very brief answer. 3.7. What is the ratio of the Aid flow from UN agencies (US$) in Brazil in 1979 to that in 1983?
Provide a short and direct response. 4.34. What is the ratio of the Aid flow from UN agencies (US$) of Lao PDR in 1979 to that in 1983?
Keep it short and to the point. 10.21. What is the ratio of the Aid flow from UN agencies (US$) in Lebanon in 1979 to that in 1983?
Your response must be concise. 0.93. What is the ratio of the Aid flow from UN agencies (US$) of Brazil in 1979 to that in 1984?
Provide a succinct answer. 0.94. What is the ratio of the Aid flow from UN agencies (US$) in Lao PDR in 1979 to that in 1984?
Provide a short and direct response. 10.4. What is the ratio of the Aid flow from UN agencies (US$) of Lebanon in 1979 to that in 1984?
Offer a very short reply. 0.84. What is the ratio of the Aid flow from UN agencies (US$) in European Union in 1979 to that in 1985?
Give a very brief answer. 6.24. What is the ratio of the Aid flow from UN agencies (US$) of Brazil in 1979 to that in 1985?
Offer a terse response. 0.66. What is the ratio of the Aid flow from UN agencies (US$) of Lao PDR in 1979 to that in 1985?
Offer a very short reply. 30.06. What is the ratio of the Aid flow from UN agencies (US$) in Lebanon in 1979 to that in 1985?
Keep it short and to the point. 0.38. What is the ratio of the Aid flow from UN agencies (US$) of European Union in 1980 to that in 1981?
Offer a terse response. 2.47. What is the ratio of the Aid flow from UN agencies (US$) in Brazil in 1980 to that in 1981?
Your response must be concise. 1.42. What is the ratio of the Aid flow from UN agencies (US$) in Lebanon in 1980 to that in 1981?
Your response must be concise. 0.91. What is the ratio of the Aid flow from UN agencies (US$) in European Union in 1980 to that in 1982?
Keep it short and to the point. 0.85. What is the ratio of the Aid flow from UN agencies (US$) in Brazil in 1980 to that in 1982?
Make the answer very short. 3.81. What is the ratio of the Aid flow from UN agencies (US$) of Lebanon in 1980 to that in 1982?
Your answer should be very brief. 0.22. What is the ratio of the Aid flow from UN agencies (US$) of European Union in 1980 to that in 1983?
Offer a terse response. 3.04. What is the ratio of the Aid flow from UN agencies (US$) of Brazil in 1980 to that in 1983?
Your answer should be compact. 4.33. What is the ratio of the Aid flow from UN agencies (US$) in Lebanon in 1980 to that in 1983?
Offer a terse response. 0.39. What is the ratio of the Aid flow from UN agencies (US$) in European Union in 1980 to that in 1984?
Keep it short and to the point. 17.27. What is the ratio of the Aid flow from UN agencies (US$) of Brazil in 1980 to that in 1984?
Offer a terse response. 0.94. What is the ratio of the Aid flow from UN agencies (US$) in Lebanon in 1980 to that in 1984?
Make the answer very short. 0.36. What is the ratio of the Aid flow from UN agencies (US$) of European Union in 1980 to that in 1985?
Your answer should be compact. 5.14. What is the ratio of the Aid flow from UN agencies (US$) in Brazil in 1980 to that in 1985?
Offer a very short reply. 0.66. What is the ratio of the Aid flow from UN agencies (US$) of Lebanon in 1980 to that in 1985?
Give a very brief answer. 0.16. What is the ratio of the Aid flow from UN agencies (US$) of European Union in 1981 to that in 1982?
Provide a short and direct response. 0.34. What is the ratio of the Aid flow from UN agencies (US$) of Brazil in 1981 to that in 1982?
Your answer should be very brief. 2.69. What is the ratio of the Aid flow from UN agencies (US$) in Lao PDR in 1981 to that in 1982?
Keep it short and to the point. 3.5. What is the ratio of the Aid flow from UN agencies (US$) of Lebanon in 1981 to that in 1982?
Ensure brevity in your answer.  0.24. What is the ratio of the Aid flow from UN agencies (US$) of European Union in 1981 to that in 1983?
Ensure brevity in your answer.  1.23. What is the ratio of the Aid flow from UN agencies (US$) in Brazil in 1981 to that in 1983?
Offer a very short reply. 3.06. What is the ratio of the Aid flow from UN agencies (US$) in Lao PDR in 1981 to that in 1983?
Offer a very short reply. 0.13. What is the ratio of the Aid flow from UN agencies (US$) in Lebanon in 1981 to that in 1983?
Provide a short and direct response. 0.43. What is the ratio of the Aid flow from UN agencies (US$) in European Union in 1981 to that in 1984?
Give a very brief answer. 7. What is the ratio of the Aid flow from UN agencies (US$) in Brazil in 1981 to that in 1984?
Your response must be concise. 0.67. What is the ratio of the Aid flow from UN agencies (US$) of Lao PDR in 1981 to that in 1984?
Make the answer very short. 0.13. What is the ratio of the Aid flow from UN agencies (US$) in Lebanon in 1981 to that in 1984?
Make the answer very short. 0.39. What is the ratio of the Aid flow from UN agencies (US$) of European Union in 1981 to that in 1985?
Give a very brief answer. 2.08. What is the ratio of the Aid flow from UN agencies (US$) of Brazil in 1981 to that in 1985?
Your response must be concise. 0.46. What is the ratio of the Aid flow from UN agencies (US$) of Lao PDR in 1981 to that in 1985?
Your answer should be very brief. 0.39. What is the ratio of the Aid flow from UN agencies (US$) of Lebanon in 1981 to that in 1985?
Offer a terse response. 0.17. What is the ratio of the Aid flow from UN agencies (US$) of European Union in 1982 to that in 1983?
Provide a succinct answer. 3.59. What is the ratio of the Aid flow from UN agencies (US$) in Brazil in 1982 to that in 1983?
Keep it short and to the point. 1.14. What is the ratio of the Aid flow from UN agencies (US$) of Lao PDR in 1982 to that in 1983?
Your answer should be very brief. 0.04. What is the ratio of the Aid flow from UN agencies (US$) of Lebanon in 1982 to that in 1983?
Provide a short and direct response. 1.81. What is the ratio of the Aid flow from UN agencies (US$) of European Union in 1982 to that in 1984?
Keep it short and to the point. 20.41. What is the ratio of the Aid flow from UN agencies (US$) of Brazil in 1982 to that in 1984?
Give a very brief answer. 0.25. What is the ratio of the Aid flow from UN agencies (US$) in Lao PDR in 1982 to that in 1984?
Offer a very short reply. 0.04. What is the ratio of the Aid flow from UN agencies (US$) in Lebanon in 1982 to that in 1984?
Ensure brevity in your answer.  1.64. What is the ratio of the Aid flow from UN agencies (US$) of European Union in 1982 to that in 1985?
Offer a terse response. 6.07. What is the ratio of the Aid flow from UN agencies (US$) of Brazil in 1982 to that in 1985?
Your answer should be compact. 0.17. What is the ratio of the Aid flow from UN agencies (US$) in Lao PDR in 1982 to that in 1985?
Provide a succinct answer. 0.11. What is the ratio of the Aid flow from UN agencies (US$) of Lebanon in 1982 to that in 1985?
Provide a succinct answer. 0.73. What is the ratio of the Aid flow from UN agencies (US$) in European Union in 1983 to that in 1984?
Offer a very short reply. 5.68. What is the ratio of the Aid flow from UN agencies (US$) of Brazil in 1983 to that in 1984?
Give a very brief answer. 0.22. What is the ratio of the Aid flow from UN agencies (US$) of Lao PDR in 1983 to that in 1984?
Make the answer very short. 1.02. What is the ratio of the Aid flow from UN agencies (US$) of Lebanon in 1983 to that in 1984?
Give a very brief answer. 0.91. What is the ratio of the Aid flow from UN agencies (US$) of European Union in 1983 to that in 1985?
Provide a short and direct response. 1.69. What is the ratio of the Aid flow from UN agencies (US$) in Brazil in 1983 to that in 1985?
Provide a short and direct response. 0.15. What is the ratio of the Aid flow from UN agencies (US$) in Lao PDR in 1983 to that in 1985?
Provide a succinct answer. 2.94. What is the ratio of the Aid flow from UN agencies (US$) in Lebanon in 1983 to that in 1985?
Your answer should be very brief. 0.4. What is the ratio of the Aid flow from UN agencies (US$) in European Union in 1984 to that in 1985?
Offer a very short reply. 0.3. What is the ratio of the Aid flow from UN agencies (US$) of Brazil in 1984 to that in 1985?
Give a very brief answer. 0.7. What is the ratio of the Aid flow from UN agencies (US$) of Lao PDR in 1984 to that in 1985?
Keep it short and to the point. 2.89. What is the ratio of the Aid flow from UN agencies (US$) in Lebanon in 1984 to that in 1985?
Offer a terse response. 0.45. What is the difference between the highest and the second highest Aid flow from UN agencies (US$) of European Union?
Provide a succinct answer. 1.09e+06. What is the difference between the highest and the second highest Aid flow from UN agencies (US$) of Brazil?
Give a very brief answer. 2.81e+06. What is the difference between the highest and the second highest Aid flow from UN agencies (US$) in Lao PDR?
Offer a very short reply. 7.90e+05. What is the difference between the highest and the second highest Aid flow from UN agencies (US$) in Lebanon?
Your answer should be compact. 3.33e+06. What is the difference between the highest and the lowest Aid flow from UN agencies (US$) in European Union?
Ensure brevity in your answer.  5.49e+06. What is the difference between the highest and the lowest Aid flow from UN agencies (US$) in Brazil?
Provide a short and direct response. 8.74e+06. What is the difference between the highest and the lowest Aid flow from UN agencies (US$) of Lao PDR?
Keep it short and to the point. 6.20e+06. What is the difference between the highest and the lowest Aid flow from UN agencies (US$) of Lebanon?
Your answer should be compact. 1.04e+07. 